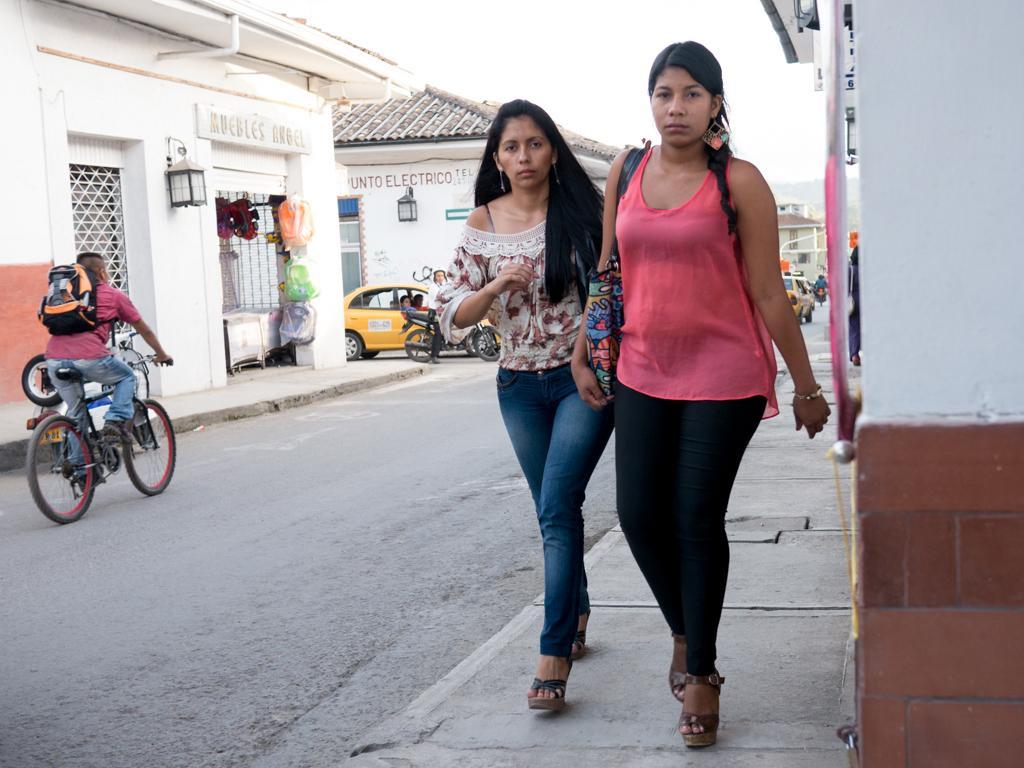Describe this image in one or two sentences. In this image, there are a few people. Among them, some people are riding motorcycles. We can see a few vehicles and a bicycle. We can see the ground. We can also see some objects attached to one of the buildings. We can see some boards with text. We can also see the sky. 